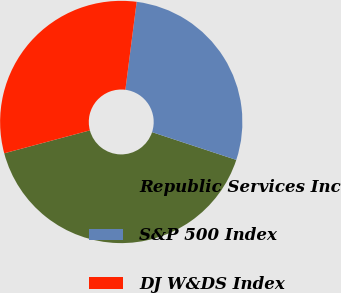Convert chart to OTSL. <chart><loc_0><loc_0><loc_500><loc_500><pie_chart><fcel>Republic Services Inc<fcel>S&P 500 Index<fcel>DJ W&DS Index<nl><fcel>40.77%<fcel>28.04%<fcel>31.2%<nl></chart> 